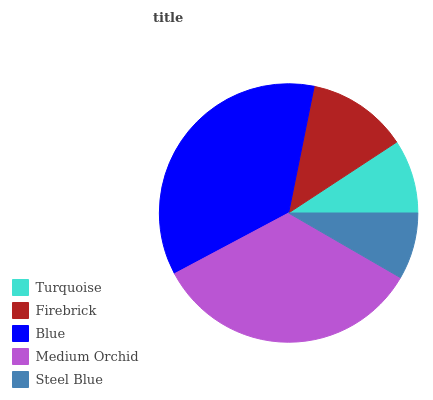Is Steel Blue the minimum?
Answer yes or no. Yes. Is Blue the maximum?
Answer yes or no. Yes. Is Firebrick the minimum?
Answer yes or no. No. Is Firebrick the maximum?
Answer yes or no. No. Is Firebrick greater than Turquoise?
Answer yes or no. Yes. Is Turquoise less than Firebrick?
Answer yes or no. Yes. Is Turquoise greater than Firebrick?
Answer yes or no. No. Is Firebrick less than Turquoise?
Answer yes or no. No. Is Firebrick the high median?
Answer yes or no. Yes. Is Firebrick the low median?
Answer yes or no. Yes. Is Medium Orchid the high median?
Answer yes or no. No. Is Medium Orchid the low median?
Answer yes or no. No. 